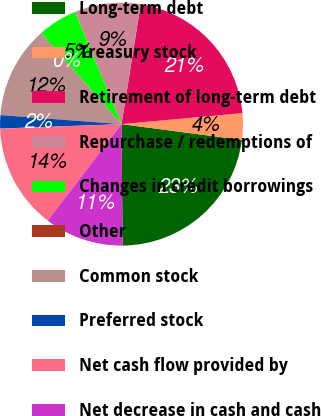Convert chart to OTSL. <chart><loc_0><loc_0><loc_500><loc_500><pie_chart><fcel>Long-term debt<fcel>Treasury stock<fcel>Retirement of long-term debt<fcel>Repurchase / redemptions of<fcel>Changes in credit borrowings<fcel>Other<fcel>Common stock<fcel>Preferred stock<fcel>Net cash flow provided by<fcel>Net decrease in cash and cash<nl><fcel>22.78%<fcel>3.52%<fcel>21.03%<fcel>8.77%<fcel>5.27%<fcel>0.02%<fcel>12.28%<fcel>1.77%<fcel>14.03%<fcel>10.53%<nl></chart> 